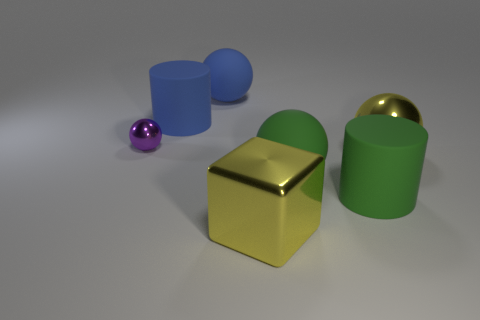Subtract all large spheres. How many spheres are left? 1 Add 1 big blue matte balls. How many objects exist? 8 Subtract all blue balls. How many balls are left? 3 Subtract 1 blocks. How many blocks are left? 0 Subtract all blocks. How many objects are left? 6 Subtract all gray blocks. Subtract all blue cylinders. How many blocks are left? 1 Subtract all brown spheres. How many blue cylinders are left? 1 Subtract all green blocks. Subtract all cubes. How many objects are left? 6 Add 6 tiny purple balls. How many tiny purple balls are left? 7 Add 4 large blue rubber cylinders. How many large blue rubber cylinders exist? 5 